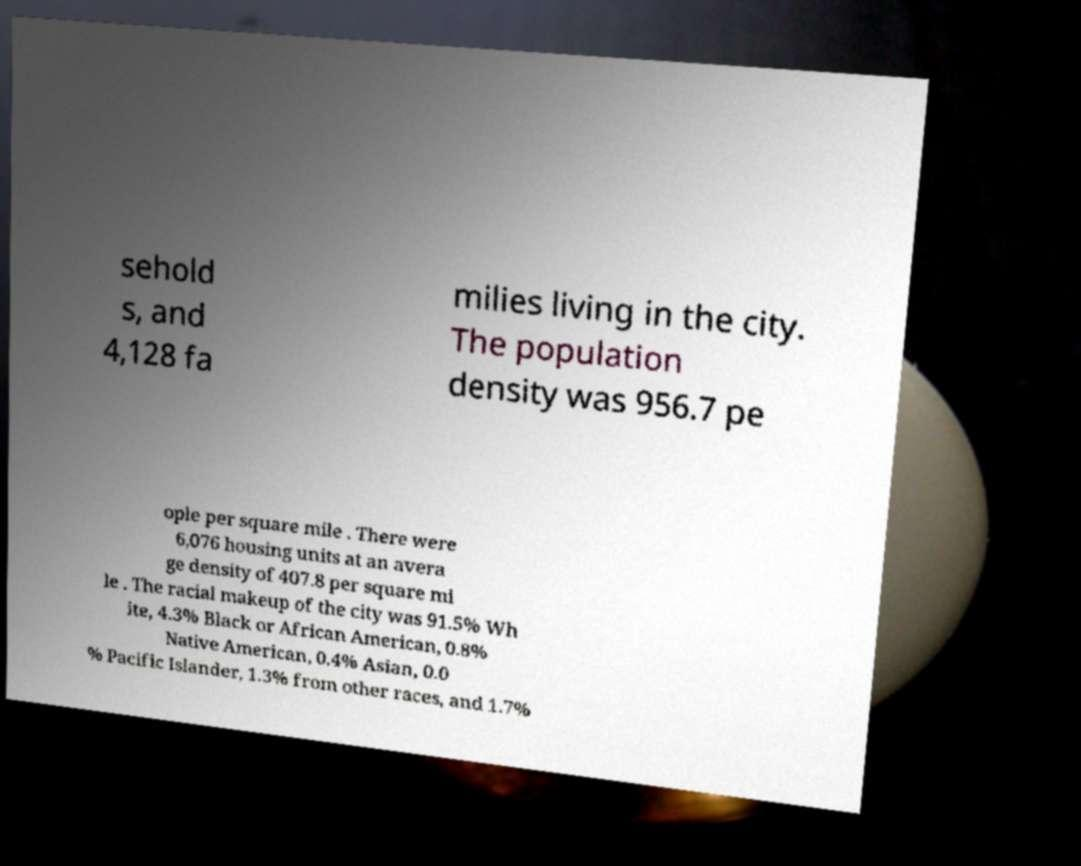I need the written content from this picture converted into text. Can you do that? sehold s, and 4,128 fa milies living in the city. The population density was 956.7 pe ople per square mile . There were 6,076 housing units at an avera ge density of 407.8 per square mi le . The racial makeup of the city was 91.5% Wh ite, 4.3% Black or African American, 0.8% Native American, 0.4% Asian, 0.0 % Pacific Islander, 1.3% from other races, and 1.7% 